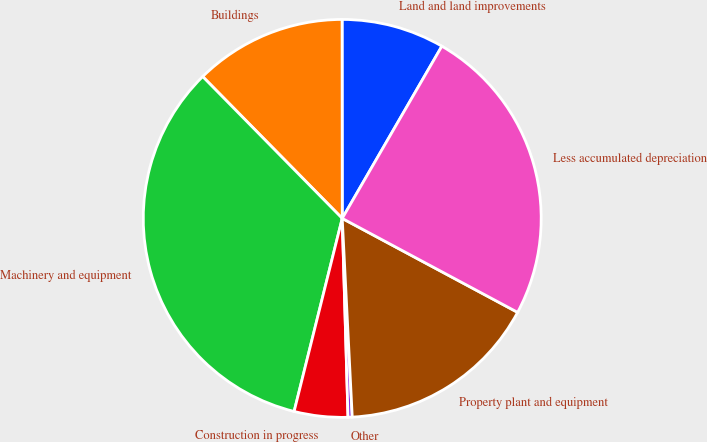<chart> <loc_0><loc_0><loc_500><loc_500><pie_chart><fcel>Land and land improvements<fcel>Buildings<fcel>Machinery and equipment<fcel>Construction in progress<fcel>Other<fcel>Property plant and equipment<fcel>Less accumulated depreciation<nl><fcel>8.36%<fcel>12.36%<fcel>33.74%<fcel>4.35%<fcel>0.34%<fcel>16.37%<fcel>24.48%<nl></chart> 